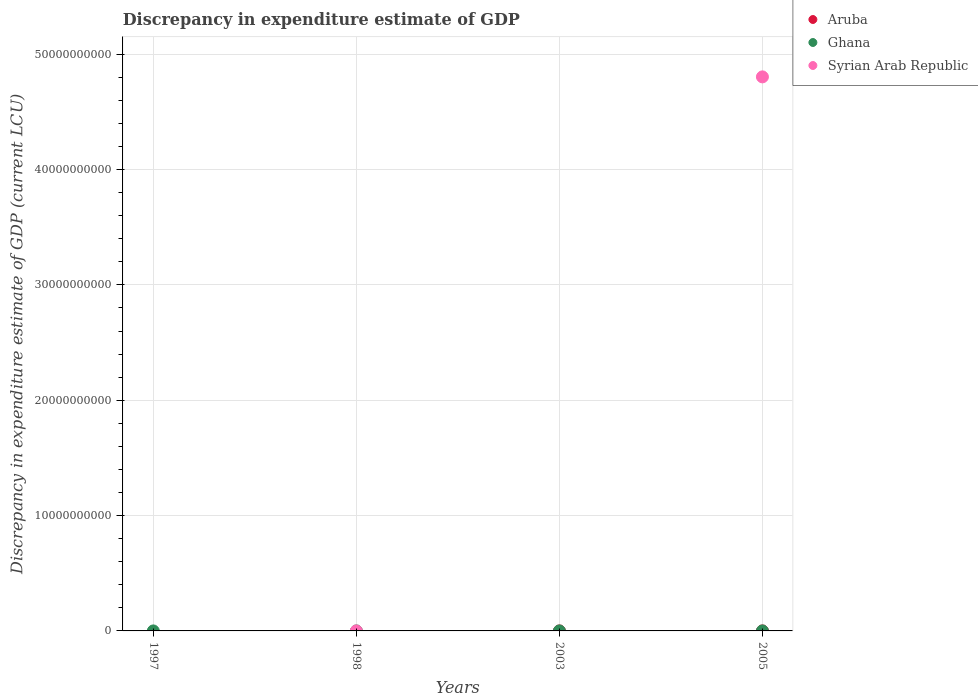Across all years, what is the maximum discrepancy in expenditure estimate of GDP in Ghana?
Offer a very short reply. 100. What is the total discrepancy in expenditure estimate of GDP in Ghana in the graph?
Your response must be concise. 200. What is the difference between the discrepancy in expenditure estimate of GDP in Ghana in 1997 and that in 2003?
Provide a short and direct response. -9.999999974752427e-7. What is the difference between the discrepancy in expenditure estimate of GDP in Aruba in 1998 and the discrepancy in expenditure estimate of GDP in Ghana in 1997?
Your answer should be very brief. -100. What is the average discrepancy in expenditure estimate of GDP in Aruba per year?
Offer a terse response. 2500. In the year 2005, what is the difference between the discrepancy in expenditure estimate of GDP in Aruba and discrepancy in expenditure estimate of GDP in Syrian Arab Republic?
Provide a succinct answer. -4.80e+1. What is the difference between the highest and the lowest discrepancy in expenditure estimate of GDP in Syrian Arab Republic?
Keep it short and to the point. 4.80e+1. In how many years, is the discrepancy in expenditure estimate of GDP in Ghana greater than the average discrepancy in expenditure estimate of GDP in Ghana taken over all years?
Keep it short and to the point. 2. Is it the case that in every year, the sum of the discrepancy in expenditure estimate of GDP in Ghana and discrepancy in expenditure estimate of GDP in Aruba  is greater than the discrepancy in expenditure estimate of GDP in Syrian Arab Republic?
Your answer should be very brief. No. Does the discrepancy in expenditure estimate of GDP in Aruba monotonically increase over the years?
Your answer should be compact. Yes. Is the discrepancy in expenditure estimate of GDP in Ghana strictly greater than the discrepancy in expenditure estimate of GDP in Aruba over the years?
Your response must be concise. No. Is the discrepancy in expenditure estimate of GDP in Aruba strictly less than the discrepancy in expenditure estimate of GDP in Ghana over the years?
Ensure brevity in your answer.  No. How many years are there in the graph?
Provide a short and direct response. 4. What is the difference between two consecutive major ticks on the Y-axis?
Your answer should be very brief. 1.00e+1. Where does the legend appear in the graph?
Your answer should be very brief. Top right. How many legend labels are there?
Offer a very short reply. 3. How are the legend labels stacked?
Your answer should be compact. Vertical. What is the title of the graph?
Offer a terse response. Discrepancy in expenditure estimate of GDP. Does "Georgia" appear as one of the legend labels in the graph?
Your response must be concise. No. What is the label or title of the Y-axis?
Your response must be concise. Discrepancy in expenditure estimate of GDP (current LCU). What is the Discrepancy in expenditure estimate of GDP (current LCU) of Aruba in 1998?
Offer a terse response. 0. What is the Discrepancy in expenditure estimate of GDP (current LCU) in Ghana in 2003?
Provide a short and direct response. 100. What is the Discrepancy in expenditure estimate of GDP (current LCU) of Syrian Arab Republic in 2003?
Your answer should be very brief. 0. What is the Discrepancy in expenditure estimate of GDP (current LCU) in Syrian Arab Republic in 2005?
Keep it short and to the point. 4.80e+1. Across all years, what is the maximum Discrepancy in expenditure estimate of GDP (current LCU) in Aruba?
Keep it short and to the point. 10000. Across all years, what is the maximum Discrepancy in expenditure estimate of GDP (current LCU) of Ghana?
Provide a short and direct response. 100. Across all years, what is the maximum Discrepancy in expenditure estimate of GDP (current LCU) in Syrian Arab Republic?
Your answer should be very brief. 4.80e+1. Across all years, what is the minimum Discrepancy in expenditure estimate of GDP (current LCU) of Ghana?
Ensure brevity in your answer.  0. What is the total Discrepancy in expenditure estimate of GDP (current LCU) of Aruba in the graph?
Keep it short and to the point. 10000. What is the total Discrepancy in expenditure estimate of GDP (current LCU) in Syrian Arab Republic in the graph?
Your answer should be compact. 4.80e+1. What is the difference between the Discrepancy in expenditure estimate of GDP (current LCU) of Ghana in 1997 and that in 2003?
Give a very brief answer. -0. What is the difference between the Discrepancy in expenditure estimate of GDP (current LCU) in Ghana in 1997 and the Discrepancy in expenditure estimate of GDP (current LCU) in Syrian Arab Republic in 2005?
Make the answer very short. -4.80e+1. What is the difference between the Discrepancy in expenditure estimate of GDP (current LCU) in Ghana in 2003 and the Discrepancy in expenditure estimate of GDP (current LCU) in Syrian Arab Republic in 2005?
Offer a very short reply. -4.80e+1. What is the average Discrepancy in expenditure estimate of GDP (current LCU) in Aruba per year?
Keep it short and to the point. 2500. What is the average Discrepancy in expenditure estimate of GDP (current LCU) of Syrian Arab Republic per year?
Keep it short and to the point. 1.20e+1. In the year 2005, what is the difference between the Discrepancy in expenditure estimate of GDP (current LCU) in Aruba and Discrepancy in expenditure estimate of GDP (current LCU) in Syrian Arab Republic?
Make the answer very short. -4.80e+1. What is the difference between the highest and the lowest Discrepancy in expenditure estimate of GDP (current LCU) of Syrian Arab Republic?
Your answer should be very brief. 4.80e+1. 